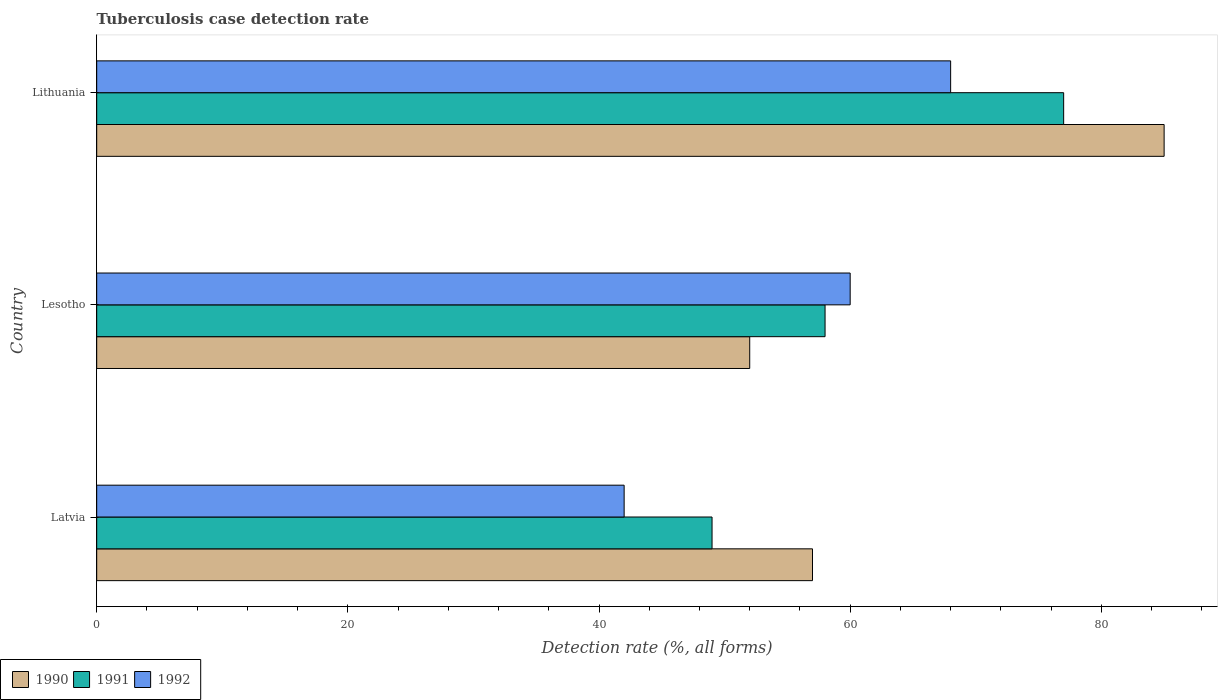Are the number of bars on each tick of the Y-axis equal?
Keep it short and to the point. Yes. How many bars are there on the 3rd tick from the top?
Your answer should be very brief. 3. How many bars are there on the 3rd tick from the bottom?
Ensure brevity in your answer.  3. What is the label of the 1st group of bars from the top?
Provide a succinct answer. Lithuania. In how many cases, is the number of bars for a given country not equal to the number of legend labels?
Make the answer very short. 0. What is the tuberculosis case detection rate in in 1992 in Latvia?
Make the answer very short. 42. In which country was the tuberculosis case detection rate in in 1991 maximum?
Keep it short and to the point. Lithuania. In which country was the tuberculosis case detection rate in in 1990 minimum?
Provide a short and direct response. Lesotho. What is the total tuberculosis case detection rate in in 1991 in the graph?
Your answer should be very brief. 184. What is the difference between the tuberculosis case detection rate in in 1991 in Lithuania and the tuberculosis case detection rate in in 1990 in Latvia?
Your response must be concise. 20. What is the average tuberculosis case detection rate in in 1991 per country?
Your answer should be very brief. 61.33. What is the ratio of the tuberculosis case detection rate in in 1990 in Latvia to that in Lithuania?
Keep it short and to the point. 0.67. Is the tuberculosis case detection rate in in 1992 in Lesotho less than that in Lithuania?
Provide a succinct answer. Yes. Is the difference between the tuberculosis case detection rate in in 1990 in Latvia and Lesotho greater than the difference between the tuberculosis case detection rate in in 1991 in Latvia and Lesotho?
Offer a very short reply. Yes. What is the difference between the highest and the lowest tuberculosis case detection rate in in 1992?
Provide a short and direct response. 26. In how many countries, is the tuberculosis case detection rate in in 1990 greater than the average tuberculosis case detection rate in in 1990 taken over all countries?
Give a very brief answer. 1. Is the sum of the tuberculosis case detection rate in in 1990 in Latvia and Lesotho greater than the maximum tuberculosis case detection rate in in 1991 across all countries?
Your response must be concise. Yes. Is it the case that in every country, the sum of the tuberculosis case detection rate in in 1990 and tuberculosis case detection rate in in 1992 is greater than the tuberculosis case detection rate in in 1991?
Provide a succinct answer. Yes. Are all the bars in the graph horizontal?
Keep it short and to the point. Yes. How many countries are there in the graph?
Your response must be concise. 3. What is the difference between two consecutive major ticks on the X-axis?
Your answer should be compact. 20. Are the values on the major ticks of X-axis written in scientific E-notation?
Offer a very short reply. No. Does the graph contain grids?
Ensure brevity in your answer.  No. How many legend labels are there?
Offer a very short reply. 3. What is the title of the graph?
Keep it short and to the point. Tuberculosis case detection rate. What is the label or title of the X-axis?
Your response must be concise. Detection rate (%, all forms). What is the label or title of the Y-axis?
Make the answer very short. Country. What is the Detection rate (%, all forms) in 1990 in Latvia?
Ensure brevity in your answer.  57. What is the Detection rate (%, all forms) in 1991 in Latvia?
Keep it short and to the point. 49. What is the Detection rate (%, all forms) of 1992 in Latvia?
Give a very brief answer. 42. What is the Detection rate (%, all forms) in 1990 in Lesotho?
Give a very brief answer. 52. What is the Detection rate (%, all forms) in 1991 in Lesotho?
Keep it short and to the point. 58. What is the Detection rate (%, all forms) of 1992 in Lesotho?
Offer a very short reply. 60. What is the Detection rate (%, all forms) in 1990 in Lithuania?
Offer a very short reply. 85. What is the Detection rate (%, all forms) of 1991 in Lithuania?
Provide a succinct answer. 77. What is the Detection rate (%, all forms) in 1992 in Lithuania?
Provide a succinct answer. 68. Across all countries, what is the maximum Detection rate (%, all forms) in 1990?
Offer a terse response. 85. Across all countries, what is the maximum Detection rate (%, all forms) in 1991?
Offer a very short reply. 77. Across all countries, what is the maximum Detection rate (%, all forms) of 1992?
Your response must be concise. 68. Across all countries, what is the minimum Detection rate (%, all forms) in 1990?
Ensure brevity in your answer.  52. Across all countries, what is the minimum Detection rate (%, all forms) in 1991?
Your answer should be very brief. 49. Across all countries, what is the minimum Detection rate (%, all forms) of 1992?
Your response must be concise. 42. What is the total Detection rate (%, all forms) of 1990 in the graph?
Make the answer very short. 194. What is the total Detection rate (%, all forms) of 1991 in the graph?
Your answer should be compact. 184. What is the total Detection rate (%, all forms) of 1992 in the graph?
Keep it short and to the point. 170. What is the difference between the Detection rate (%, all forms) in 1990 in Latvia and that in Lesotho?
Keep it short and to the point. 5. What is the difference between the Detection rate (%, all forms) in 1992 in Latvia and that in Lesotho?
Offer a very short reply. -18. What is the difference between the Detection rate (%, all forms) in 1992 in Latvia and that in Lithuania?
Your answer should be very brief. -26. What is the difference between the Detection rate (%, all forms) in 1990 in Lesotho and that in Lithuania?
Offer a very short reply. -33. What is the difference between the Detection rate (%, all forms) of 1991 in Lesotho and that in Lithuania?
Offer a very short reply. -19. What is the difference between the Detection rate (%, all forms) in 1992 in Lesotho and that in Lithuania?
Offer a very short reply. -8. What is the difference between the Detection rate (%, all forms) in 1990 in Latvia and the Detection rate (%, all forms) in 1991 in Lesotho?
Offer a very short reply. -1. What is the difference between the Detection rate (%, all forms) in 1990 in Latvia and the Detection rate (%, all forms) in 1991 in Lithuania?
Keep it short and to the point. -20. What is the difference between the Detection rate (%, all forms) of 1991 in Latvia and the Detection rate (%, all forms) of 1992 in Lithuania?
Make the answer very short. -19. What is the difference between the Detection rate (%, all forms) in 1990 in Lesotho and the Detection rate (%, all forms) in 1991 in Lithuania?
Make the answer very short. -25. What is the difference between the Detection rate (%, all forms) in 1990 in Lesotho and the Detection rate (%, all forms) in 1992 in Lithuania?
Your answer should be compact. -16. What is the average Detection rate (%, all forms) in 1990 per country?
Your answer should be compact. 64.67. What is the average Detection rate (%, all forms) of 1991 per country?
Provide a succinct answer. 61.33. What is the average Detection rate (%, all forms) in 1992 per country?
Your answer should be very brief. 56.67. What is the difference between the Detection rate (%, all forms) of 1991 and Detection rate (%, all forms) of 1992 in Latvia?
Offer a terse response. 7. What is the difference between the Detection rate (%, all forms) of 1990 and Detection rate (%, all forms) of 1991 in Lesotho?
Offer a very short reply. -6. What is the difference between the Detection rate (%, all forms) of 1990 and Detection rate (%, all forms) of 1992 in Lesotho?
Ensure brevity in your answer.  -8. What is the difference between the Detection rate (%, all forms) in 1990 and Detection rate (%, all forms) in 1992 in Lithuania?
Provide a succinct answer. 17. What is the ratio of the Detection rate (%, all forms) in 1990 in Latvia to that in Lesotho?
Your answer should be compact. 1.1. What is the ratio of the Detection rate (%, all forms) in 1991 in Latvia to that in Lesotho?
Offer a terse response. 0.84. What is the ratio of the Detection rate (%, all forms) in 1992 in Latvia to that in Lesotho?
Keep it short and to the point. 0.7. What is the ratio of the Detection rate (%, all forms) in 1990 in Latvia to that in Lithuania?
Give a very brief answer. 0.67. What is the ratio of the Detection rate (%, all forms) of 1991 in Latvia to that in Lithuania?
Your answer should be compact. 0.64. What is the ratio of the Detection rate (%, all forms) of 1992 in Latvia to that in Lithuania?
Give a very brief answer. 0.62. What is the ratio of the Detection rate (%, all forms) in 1990 in Lesotho to that in Lithuania?
Keep it short and to the point. 0.61. What is the ratio of the Detection rate (%, all forms) in 1991 in Lesotho to that in Lithuania?
Provide a succinct answer. 0.75. What is the ratio of the Detection rate (%, all forms) in 1992 in Lesotho to that in Lithuania?
Offer a terse response. 0.88. What is the difference between the highest and the second highest Detection rate (%, all forms) of 1992?
Your response must be concise. 8. What is the difference between the highest and the lowest Detection rate (%, all forms) of 1991?
Your response must be concise. 28. What is the difference between the highest and the lowest Detection rate (%, all forms) in 1992?
Your answer should be compact. 26. 